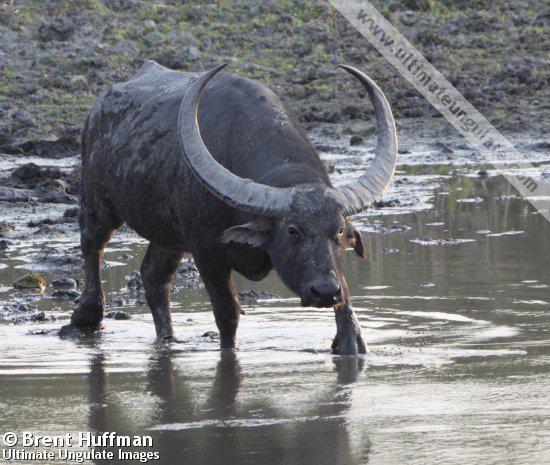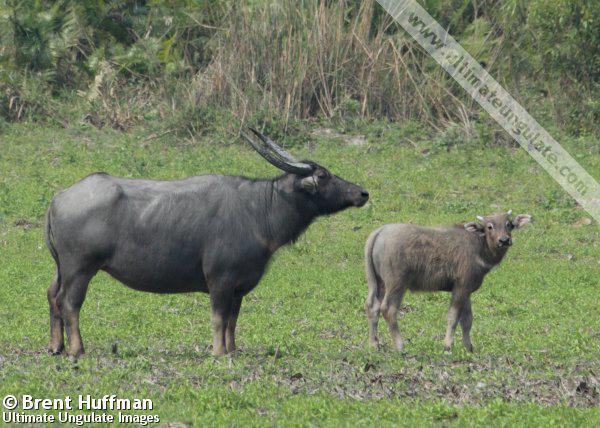The first image is the image on the left, the second image is the image on the right. Evaluate the accuracy of this statement regarding the images: "A water buffalo is standing on a body of water.". Is it true? Answer yes or no. Yes. The first image is the image on the left, the second image is the image on the right. For the images displayed, is the sentence "There is a single black buffalo with horns over a foot long facing left in a field of grass." factually correct? Answer yes or no. No. The first image is the image on the left, the second image is the image on the right. Analyze the images presented: Is the assertion "An image shows exactly one water buffalo, which is standing in muddy water." valid? Answer yes or no. Yes. The first image is the image on the left, the second image is the image on the right. Considering the images on both sides, is "Is one of the image there is a water buffalo standing in the water." valid? Answer yes or no. Yes. 